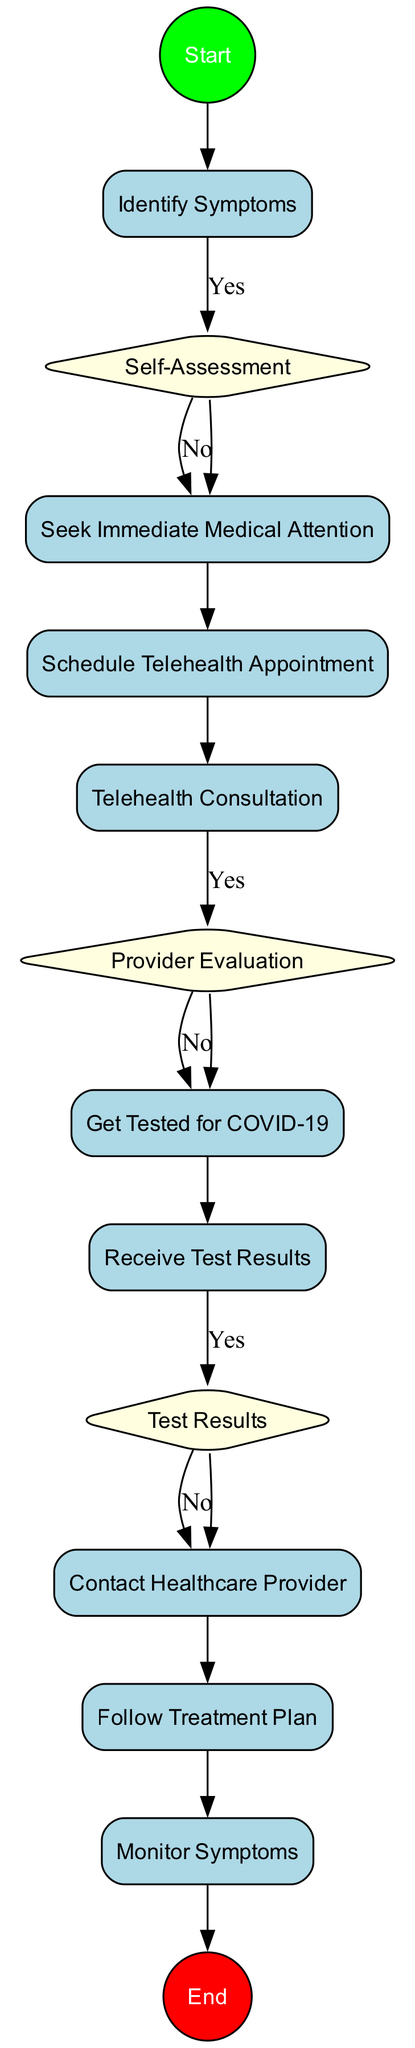What is the first activity in the diagram? The first activity is depicted immediately after the start node, which is labeled "Identify Symptoms." Therefore, it is the initial step taken upon recognizing potential COVID-19 symptoms.
Answer: Identify Symptoms How many decision nodes are there in the diagram? By counting the nodes labeled as "decision," there are three decision nodes present in the diagram, each representing a point where a choice is made based on conditions.
Answer: 3 What happens if the self-assessment indicates severe symptoms? If the self-assessment indicates severe symptoms, the next action dictated by the flow is to "Seek Immediate Medical Attention," which involves contacting emergency services or going to the nearest hospital.
Answer: Seek Immediate Medical Attention What must a healthcare provider evaluate? A healthcare provider must evaluate whether to recommend COVID-19 testing, which is explicitly indicated in the decision node labeled "Provider Evaluation."
Answer: Recommend COVID-19 testing What is the last activity in the diagram? The last activity depicted before reaching the end node is "Monitor Symptoms," indicating that ongoing monitoring of symptoms is the final step in the process.
Answer: Monitor Symptoms What action must be taken if the COVID-19 test result is positive? If the COVID-19 test result is positive, the diagram instructs to "Contact Healthcare Provider" to discuss the treatment plan, highlighting the next action based on the positive outcome.
Answer: Contact Healthcare Provider What condition checks whether to seek medical attention? The condition checking whether to seek medical attention is represented in the decision node titled "Self-Assessment," which asks if symptoms are severe.
Answer: Are symptoms severe? What do you do after receiving test results? After receiving test results, the next step involves checking the outcome; if positive, the action is to contact the healthcare provider, as specified in the flow.
Answer: Check test results What is the primary purpose of the telehealth consultation? The primary purpose of the telehealth consultation is to discuss symptoms and medical history with a healthcare provider, ensuring that pertinent information is communicated remotely.
Answer: Discuss symptoms and medical history 